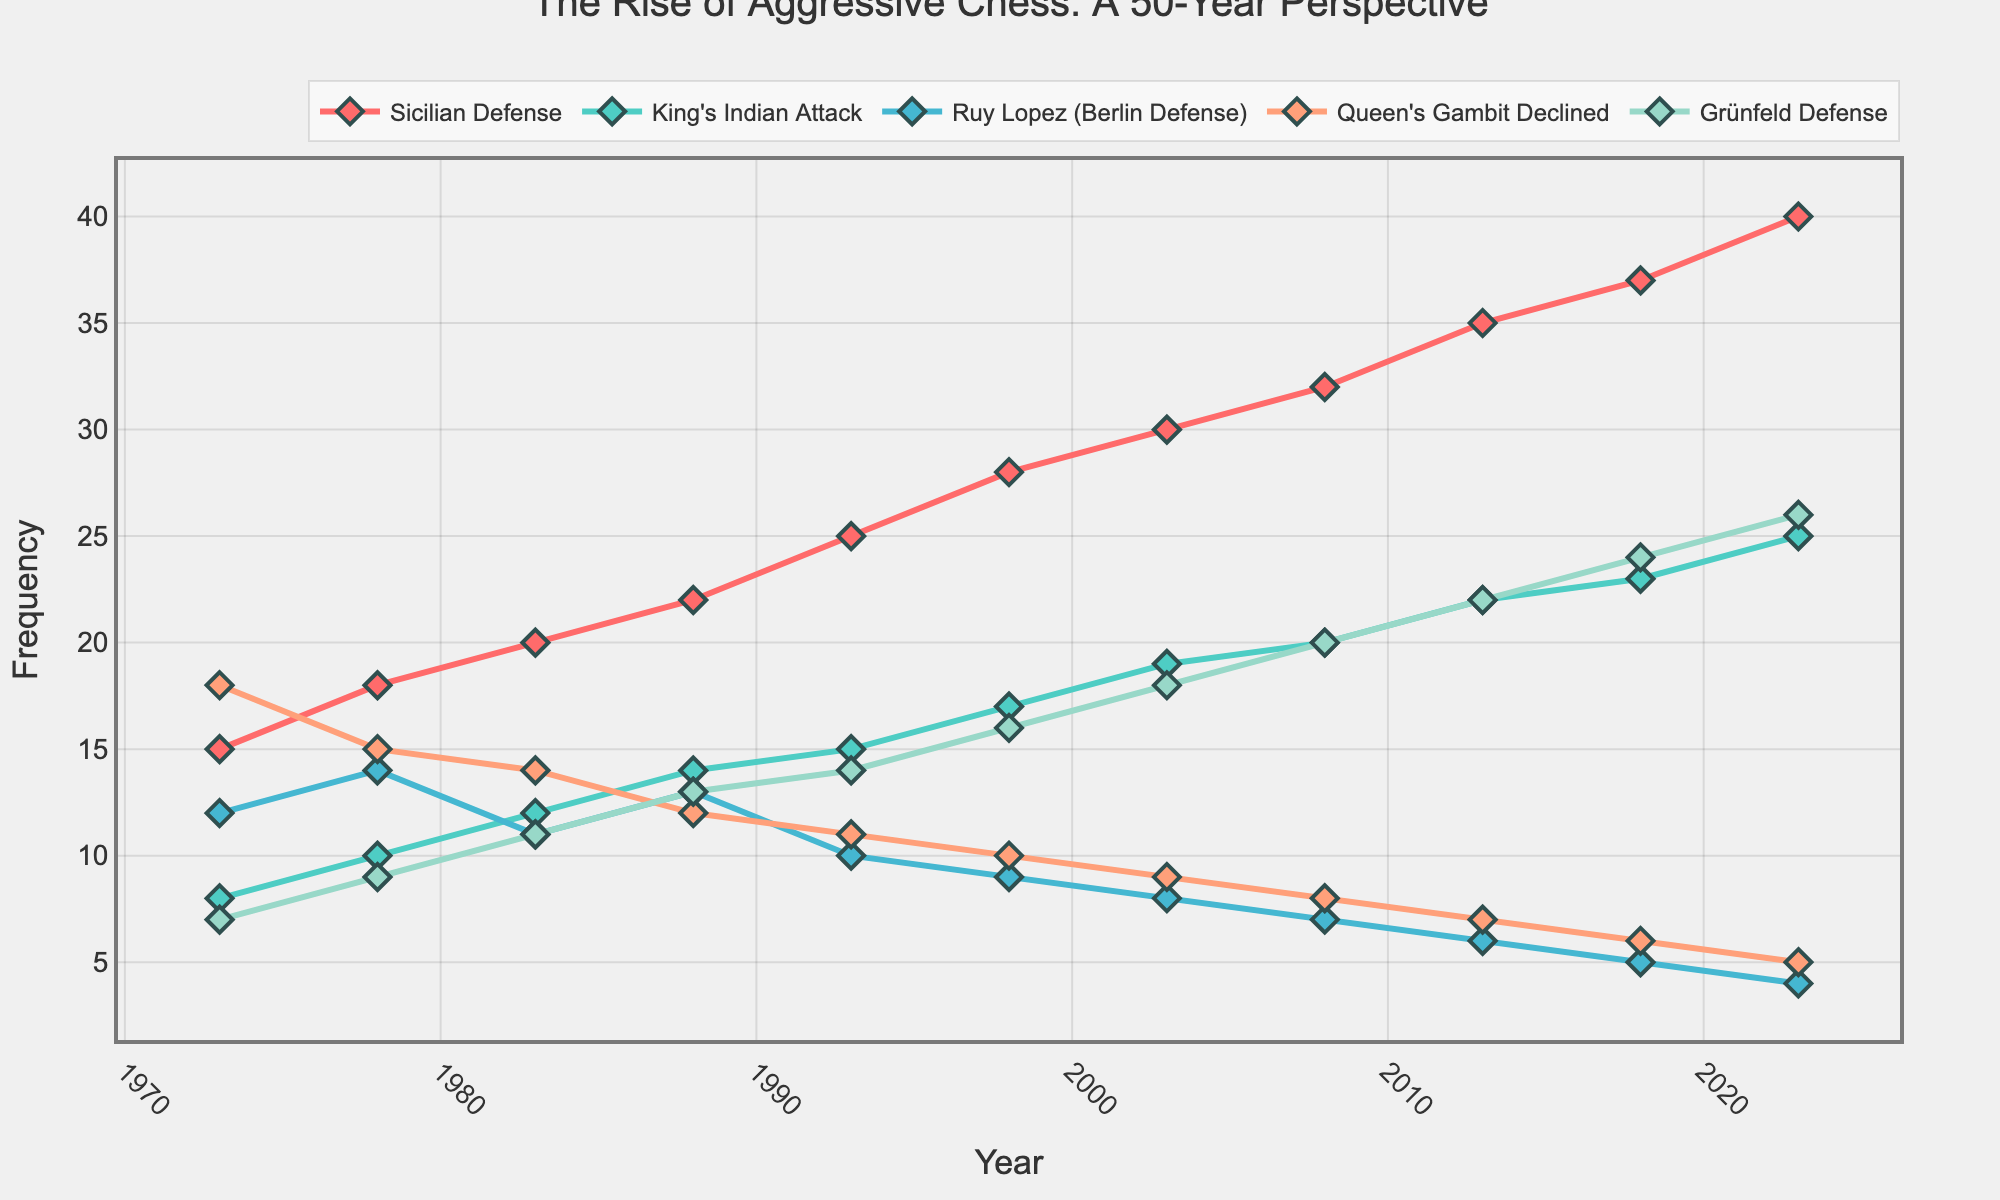What is the overall trend for the Sicilian Defense from 1973 to 2023? To identify the trend, observe the data points for the Sicilian Defense line from 1973 to 2023. The frequency starts at 15 and increases gradually to 40 over the 50-year period. Thus, the overall trend is upward.
Answer: Upward Which opening had the highest frequency in 2023? Look at the values for each opening in the year 2023. The Sicilian Defense has the highest frequency with a value of 40.
Answer: Sicilian Defense Comparing the Ruy Lopez (Berlin Defense) and Queen's Gambit Declined, which has shown a sharper decline over the period? Observe the initial and final frequencies for both openings. The Ruy Lopez (Berlin Defense) goes from 12 to 4, and the Queen's Gambit Declined goes from 18 to 5. The difference for Ruy Lopez is -8, and for Queen's Gambit is -13. Thus, the Queen's Gambit Declined shows a sharper decline.
Answer: Queen's Gambit Declined Calculate the average frequency of the King's Indian Attack moves over the 50 years. Sum the frequencies across all the years (8 + 10 + 12 + 14 + 15 + 17 + 19 + 20 + 22 + 23 + 25) = 185. Divide by the number of data points (11).
Answer: 16.82 Which openings crossed the 20 frequency mark and when did they do so? Check the data to see when each opening first reaches or surpasses 20. The Sicilian Defense crossed in 1993, the King's Indian Attack in 2008, and the Grünfeld Defense in 2008.
Answer: Sicilian Defense (1993), King's Indian Attack (2008), Grünfeld Defense (2008) How does the frequency of the Grünfeld Defense in 1983 compare to its frequency in 1993? Look at the values for the Grünfeld Defense in these two years. In 1983, it is 11, and in 1993, it is 14. The frequency in 1993 is higher.
Answer: 1993 is higher Multiply the frequencies of the Sicilian Defense and King's Indian Attack in 2023. What is the product? The frequencies are 40 and 25, respectively. Multiply them: 40 * 25 = 1000.
Answer: 1000 Which opening showed the most consistent increase over time? Assess the variability and overall trend in the lines for each opening. The Sicilian Defense shows a consistent steady increase without fluctuations from 1973 to 2023.
Answer: Sicilian Defense Identify the opening with the least frequency in the year 2018. Look at the values for 2018 across all openings. The Ruy Lopez (Berlin Defense) has the smallest frequency of 5.
Answer: Ruy Lopez (Berlin Defense) Compare the initial and final years’ frequency of the King's Indian Attack and determine the percentage increase. The King's Indian Attack goes from 8 (1973) to 25 (2023). The percentage increase is calculated as ((25-8)/8) * 100 = 212.5%.
Answer: 212.5% 